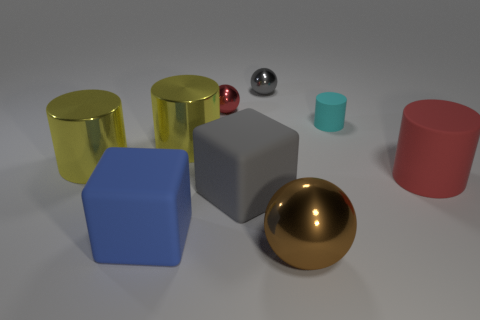How many tiny shiny spheres are the same color as the large rubber cylinder?
Provide a short and direct response. 1. Is the number of tiny red metallic objects in front of the gray matte thing less than the number of big metallic balls?
Provide a succinct answer. Yes. Is the shape of the gray shiny thing the same as the blue object?
Ensure brevity in your answer.  No. There is a matte cylinder behind the big metallic cylinder that is to the left of the large yellow metal thing to the right of the blue cube; how big is it?
Keep it short and to the point. Small. There is a red object that is the same shape as the gray metallic thing; what material is it?
Make the answer very short. Metal. How big is the ball in front of the red object behind the cyan object?
Make the answer very short. Large. The large rubber cylinder has what color?
Ensure brevity in your answer.  Red. There is a small gray ball on the left side of the big brown metallic sphere; how many small shiny objects are in front of it?
Your response must be concise. 1. Are there any tiny red metal things that are left of the tiny sphere that is to the left of the large gray rubber thing?
Make the answer very short. No. There is a large blue matte object; are there any gray matte objects to the right of it?
Make the answer very short. Yes. 